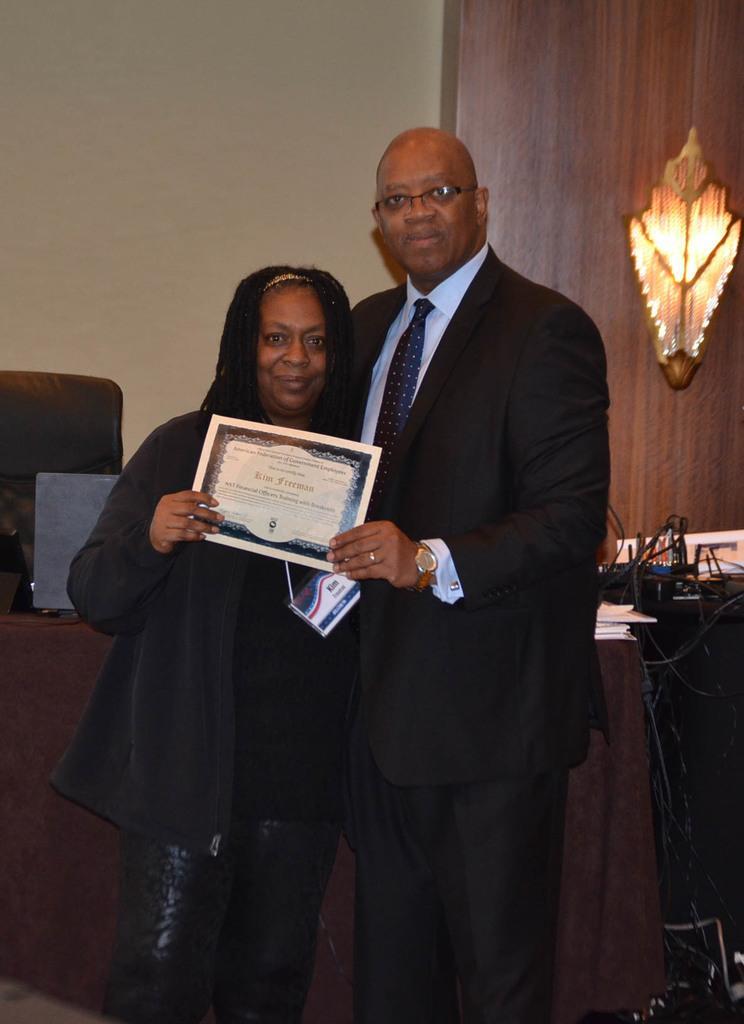How would you summarize this image in a sentence or two? In the image there is a man and a woman. Both are holding a certificate together, behind them there is a table and on the table there are some gadgets, books and wires. In the background there is a wall and beside the wall there is a lamp fixed to a wooden surface. 